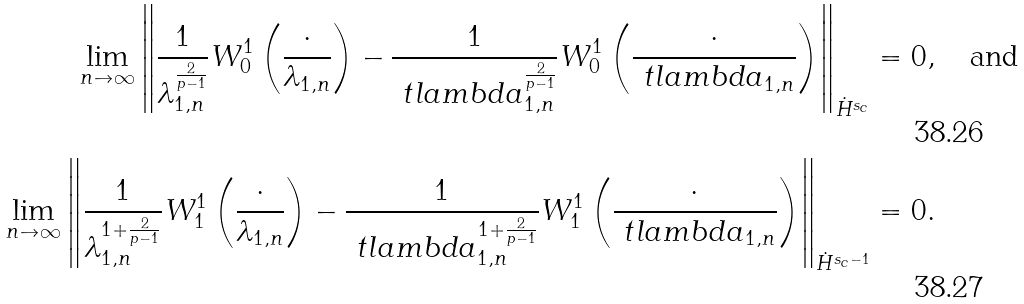Convert formula to latex. <formula><loc_0><loc_0><loc_500><loc_500>\lim _ { n \to \infty } \left \| \frac { 1 } { \lambda _ { 1 , n } ^ { \frac { 2 } { p - 1 } } } W _ { 0 } ^ { 1 } \left ( \frac { \cdot } { \lambda _ { 1 , n } } \right ) - \frac { 1 } { \ t l a m b d a _ { 1 , n } ^ { \frac { 2 } { p - 1 } } } W _ { 0 } ^ { 1 } \left ( \frac { \cdot } { \ t l a m b d a _ { 1 , n } } \right ) \right \| _ { \dot { H } ^ { s _ { c } } } & = 0 , \quad \text {and} \\ \lim _ { n \to \infty } \left \| \frac { 1 } { \lambda _ { 1 , n } ^ { 1 + \frac { 2 } { p - 1 } } } W _ { 1 } ^ { 1 } \left ( \frac { \cdot } { \lambda _ { 1 , n } } \right ) - \frac { 1 } { \ t l a m b d a _ { 1 , n } ^ { 1 + \frac { 2 } { p - 1 } } } W _ { 1 } ^ { 1 } \left ( \frac { \cdot } { \ t l a m b d a _ { 1 , n } } \right ) \right \| _ { \dot { H } ^ { s _ { c } - 1 } } & = 0 .</formula> 